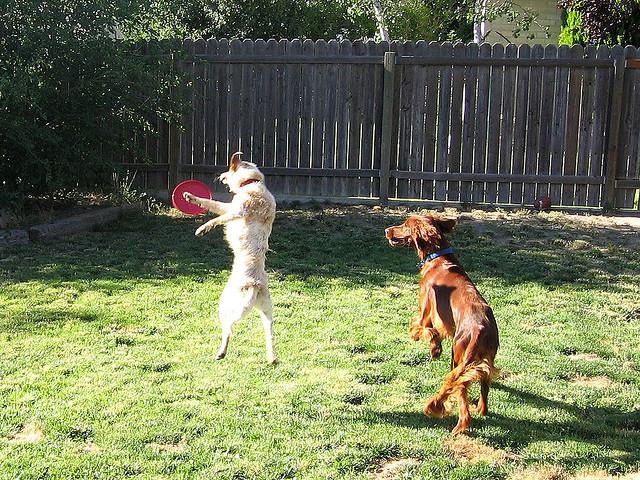What color is the dog on the left?
Be succinct. White. What type of fence is in the background?
Short answer required. Wooden. Where does dog playing?
Be succinct. Yard. What is the dog playing with?
Concise answer only. Frisbee. 